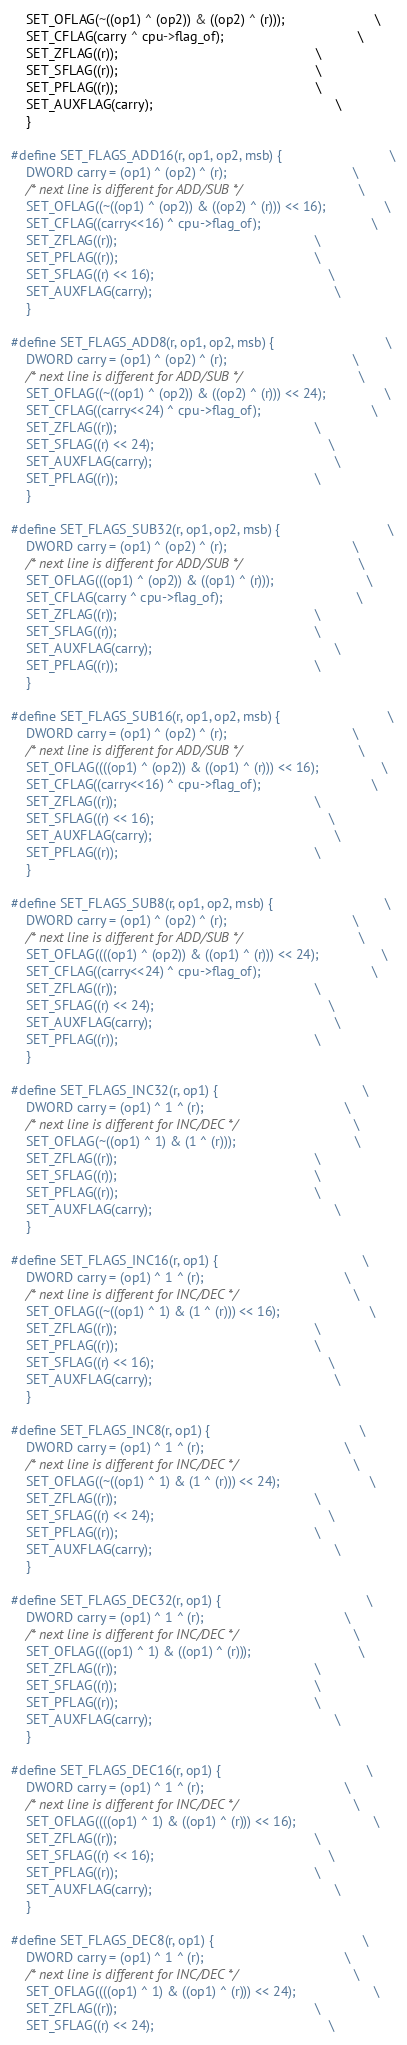Convert code to text. <code><loc_0><loc_0><loc_500><loc_500><_C_>    SET_OFLAG(~((op1) ^ (op2)) & ((op2) ^ (r)));                        \
    SET_CFLAG(carry ^ cpu->flag_of);                                    \
    SET_ZFLAG((r));                                                     \
    SET_SFLAG((r));                                                     \
    SET_PFLAG((r));                                                     \
    SET_AUXFLAG(carry);                                                 \
    }

#define SET_FLAGS_ADD16(r, op1, op2, msb) {                             \
    DWORD carry = (op1) ^ (op2) ^ (r);                                  \
    /* next line is different for ADD/SUB */                            \
    SET_OFLAG((~((op1) ^ (op2)) & ((op2) ^ (r))) << 16);                \
    SET_CFLAG((carry<<16) ^ cpu->flag_of);                              \
    SET_ZFLAG((r));                                                     \
    SET_PFLAG((r));                                                     \
    SET_SFLAG((r) << 16);                                               \
    SET_AUXFLAG(carry);                                                 \
    }

#define SET_FLAGS_ADD8(r, op1, op2, msb) {                              \
    DWORD carry = (op1) ^ (op2) ^ (r);                                  \
    /* next line is different for ADD/SUB */                            \
    SET_OFLAG((~((op1) ^ (op2)) & ((op2) ^ (r))) << 24);                \
    SET_CFLAG((carry<<24) ^ cpu->flag_of);                              \
    SET_ZFLAG((r));                                                     \
    SET_SFLAG((r) << 24);                                               \
    SET_AUXFLAG(carry);                                                 \
    SET_PFLAG((r));                                                     \
    }

#define SET_FLAGS_SUB32(r, op1, op2, msb) {                             \
    DWORD carry = (op1) ^ (op2) ^ (r);                                  \
    /* next line is different for ADD/SUB */                            \
    SET_OFLAG(((op1) ^ (op2)) & ((op1) ^ (r)));                         \
    SET_CFLAG(carry ^ cpu->flag_of);                                    \
    SET_ZFLAG((r));                                                     \
    SET_SFLAG((r));                                                     \
    SET_AUXFLAG(carry);                                                 \
    SET_PFLAG((r));                                                     \
    }

#define SET_FLAGS_SUB16(r, op1, op2, msb) {                             \
    DWORD carry = (op1) ^ (op2) ^ (r);                                  \
    /* next line is different for ADD/SUB */                            \
    SET_OFLAG((((op1) ^ (op2)) & ((op1) ^ (r))) << 16);                 \
    SET_CFLAG((carry<<16) ^ cpu->flag_of);                              \
    SET_ZFLAG((r));                                                     \
    SET_SFLAG((r) << 16);                                               \
    SET_AUXFLAG(carry);                                                 \
    SET_PFLAG((r));                                                     \
    }

#define SET_FLAGS_SUB8(r, op1, op2, msb) {                              \
    DWORD carry = (op1) ^ (op2) ^ (r);                                  \
    /* next line is different for ADD/SUB */                            \
    SET_OFLAG((((op1) ^ (op2)) & ((op1) ^ (r))) << 24);                 \
    SET_CFLAG((carry<<24) ^ cpu->flag_of);                              \
    SET_ZFLAG((r));                                                     \
    SET_SFLAG((r) << 24);                                               \
    SET_AUXFLAG(carry);                                                 \
    SET_PFLAG((r));                                                     \
    }

#define SET_FLAGS_INC32(r, op1) {                                       \
    DWORD carry = (op1) ^ 1 ^ (r);                                      \
    /* next line is different for INC/DEC */                            \
    SET_OFLAG(~((op1) ^ 1) & (1 ^ (r)));                                \
    SET_ZFLAG((r));                                                     \
    SET_SFLAG((r));                                                     \
    SET_PFLAG((r));                                                     \
    SET_AUXFLAG(carry);                                                 \
    }

#define SET_FLAGS_INC16(r, op1) {                                       \
    DWORD carry = (op1) ^ 1 ^ (r);                                      \
    /* next line is different for INC/DEC */                            \
    SET_OFLAG((~((op1) ^ 1) & (1 ^ (r))) << 16);                        \
    SET_ZFLAG((r));                                                     \
    SET_PFLAG((r));                                                     \
    SET_SFLAG((r) << 16);                                               \
    SET_AUXFLAG(carry);                                                 \
    }

#define SET_FLAGS_INC8(r, op1) {                                        \
    DWORD carry = (op1) ^ 1 ^ (r);                                      \
    /* next line is different for INC/DEC */                            \
    SET_OFLAG((~((op1) ^ 1) & (1 ^ (r))) << 24);                        \
    SET_ZFLAG((r));                                                     \
    SET_SFLAG((r) << 24);                                               \
    SET_PFLAG((r));                                                     \
    SET_AUXFLAG(carry);                                                 \
    }

#define SET_FLAGS_DEC32(r, op1) {                                       \
    DWORD carry = (op1) ^ 1 ^ (r);                                      \
    /* next line is different for INC/DEC */                            \
    SET_OFLAG(((op1) ^ 1) & ((op1) ^ (r)));                             \
    SET_ZFLAG((r));                                                     \
    SET_SFLAG((r));                                                     \
    SET_PFLAG((r));                                                     \
    SET_AUXFLAG(carry);                                                 \
    }

#define SET_FLAGS_DEC16(r, op1) {                                       \
    DWORD carry = (op1) ^ 1 ^ (r);                                      \
    /* next line is different for INC/DEC */                            \
    SET_OFLAG((((op1) ^ 1) & ((op1) ^ (r))) << 16);                     \
    SET_ZFLAG((r));                                                     \
    SET_SFLAG((r) << 16);                                               \
    SET_PFLAG((r));                                                     \
    SET_AUXFLAG(carry);                                                 \
    }

#define SET_FLAGS_DEC8(r, op1) {                                        \
    DWORD carry = (op1) ^ 1 ^ (r);                                      \
    /* next line is different for INC/DEC */                            \
    SET_OFLAG((((op1) ^ 1) & ((op1) ^ (r))) << 24);                     \
    SET_ZFLAG((r));                                                     \
    SET_SFLAG((r) << 24);                                               \</code> 